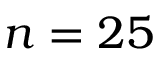<formula> <loc_0><loc_0><loc_500><loc_500>n = 2 5</formula> 